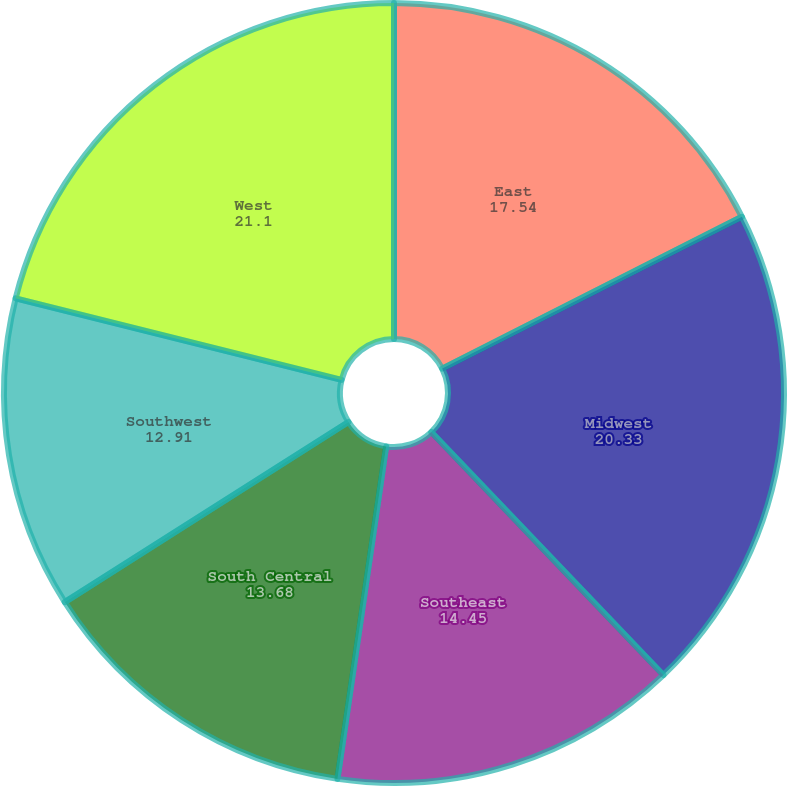Convert chart to OTSL. <chart><loc_0><loc_0><loc_500><loc_500><pie_chart><fcel>East<fcel>Midwest<fcel>Southeast<fcel>South Central<fcel>Southwest<fcel>West<nl><fcel>17.54%<fcel>20.33%<fcel>14.45%<fcel>13.68%<fcel>12.91%<fcel>21.1%<nl></chart> 